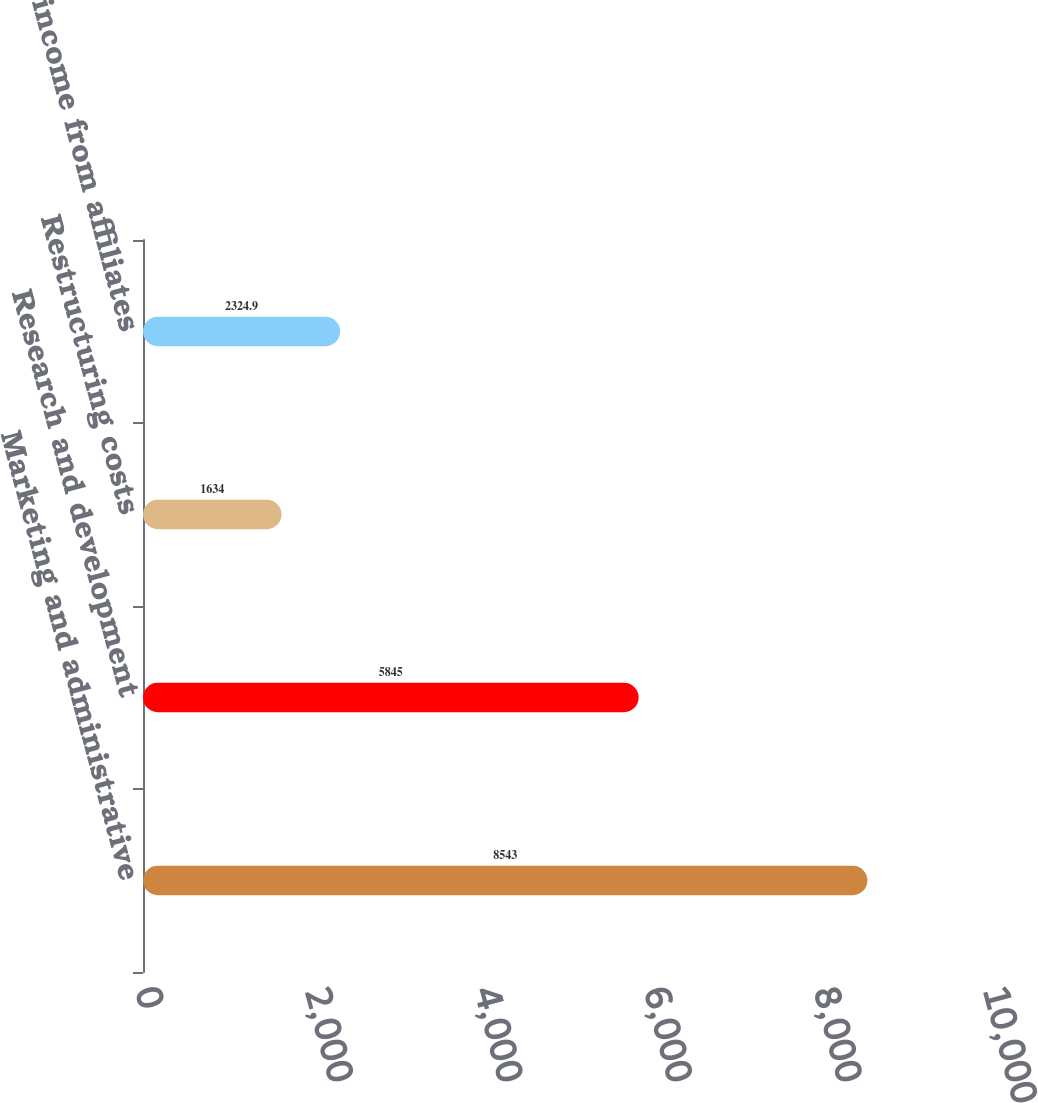Convert chart to OTSL. <chart><loc_0><loc_0><loc_500><loc_500><bar_chart><fcel>Marketing and administrative<fcel>Research and development<fcel>Restructuring costs<fcel>Equity income from affiliates<nl><fcel>8543<fcel>5845<fcel>1634<fcel>2324.9<nl></chart> 